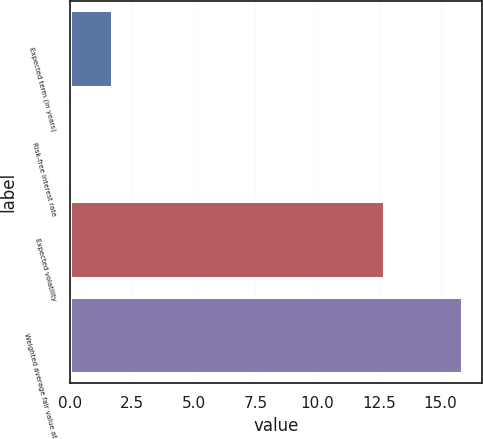Convert chart to OTSL. <chart><loc_0><loc_0><loc_500><loc_500><bar_chart><fcel>Expected term (in years)<fcel>Risk-free interest rate<fcel>Expected volatility<fcel>Weighted average fair value at<nl><fcel>1.68<fcel>0.1<fcel>12.7<fcel>15.87<nl></chart> 